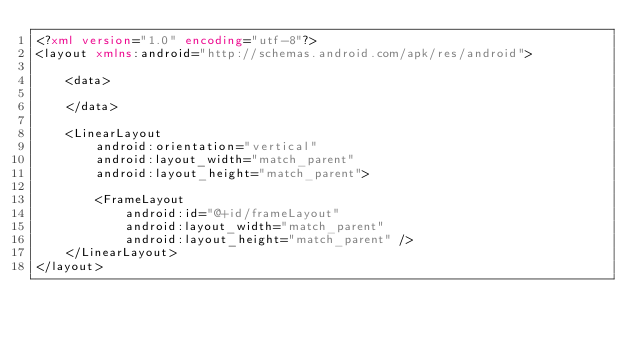<code> <loc_0><loc_0><loc_500><loc_500><_XML_><?xml version="1.0" encoding="utf-8"?>
<layout xmlns:android="http://schemas.android.com/apk/res/android">

    <data>

    </data>

    <LinearLayout
        android:orientation="vertical"
        android:layout_width="match_parent"
        android:layout_height="match_parent">

        <FrameLayout
            android:id="@+id/frameLayout"
            android:layout_width="match_parent"
            android:layout_height="match_parent" />
    </LinearLayout>
</layout></code> 